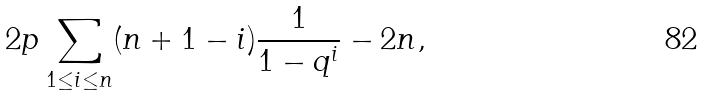<formula> <loc_0><loc_0><loc_500><loc_500>2 p \sum _ { 1 \leq i \leq n } ( n + 1 - i ) \frac { 1 } { 1 - q ^ { i } } - 2 n ,</formula> 